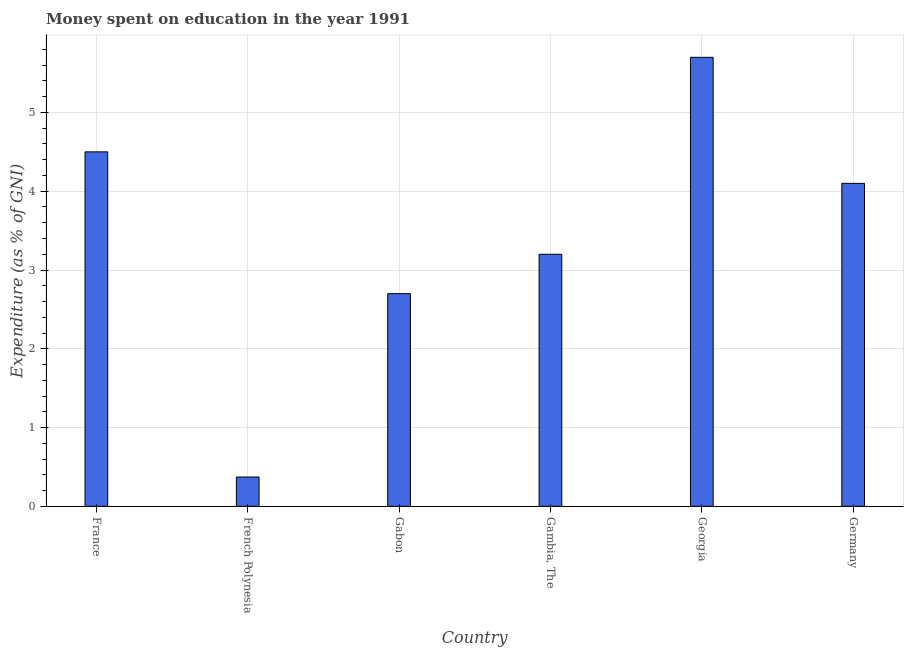What is the title of the graph?
Offer a very short reply. Money spent on education in the year 1991. What is the label or title of the X-axis?
Your answer should be very brief. Country. What is the label or title of the Y-axis?
Offer a terse response. Expenditure (as % of GNI). Across all countries, what is the minimum expenditure on education?
Give a very brief answer. 0.37. In which country was the expenditure on education maximum?
Offer a terse response. Georgia. In which country was the expenditure on education minimum?
Keep it short and to the point. French Polynesia. What is the sum of the expenditure on education?
Give a very brief answer. 20.57. What is the average expenditure on education per country?
Your answer should be very brief. 3.43. What is the median expenditure on education?
Provide a succinct answer. 3.65. In how many countries, is the expenditure on education greater than 4.6 %?
Your answer should be very brief. 1. What is the ratio of the expenditure on education in French Polynesia to that in Gambia, The?
Your answer should be very brief. 0.12. Is the expenditure on education in France less than that in Gambia, The?
Offer a terse response. No. Is the sum of the expenditure on education in French Polynesia and Georgia greater than the maximum expenditure on education across all countries?
Offer a very short reply. Yes. What is the difference between the highest and the lowest expenditure on education?
Make the answer very short. 5.33. Are all the bars in the graph horizontal?
Your answer should be compact. No. How many countries are there in the graph?
Ensure brevity in your answer.  6. What is the difference between two consecutive major ticks on the Y-axis?
Offer a very short reply. 1. What is the Expenditure (as % of GNI) of France?
Offer a very short reply. 4.5. What is the Expenditure (as % of GNI) of French Polynesia?
Your response must be concise. 0.37. What is the Expenditure (as % of GNI) of Georgia?
Give a very brief answer. 5.7. What is the difference between the Expenditure (as % of GNI) in France and French Polynesia?
Ensure brevity in your answer.  4.13. What is the difference between the Expenditure (as % of GNI) in France and Gabon?
Your answer should be compact. 1.8. What is the difference between the Expenditure (as % of GNI) in France and Gambia, The?
Your answer should be very brief. 1.3. What is the difference between the Expenditure (as % of GNI) in France and Georgia?
Ensure brevity in your answer.  -1.2. What is the difference between the Expenditure (as % of GNI) in France and Germany?
Your response must be concise. 0.4. What is the difference between the Expenditure (as % of GNI) in French Polynesia and Gabon?
Your answer should be very brief. -2.33. What is the difference between the Expenditure (as % of GNI) in French Polynesia and Gambia, The?
Keep it short and to the point. -2.83. What is the difference between the Expenditure (as % of GNI) in French Polynesia and Georgia?
Ensure brevity in your answer.  -5.33. What is the difference between the Expenditure (as % of GNI) in French Polynesia and Germany?
Provide a short and direct response. -3.73. What is the difference between the Expenditure (as % of GNI) in Gabon and Gambia, The?
Your response must be concise. -0.5. What is the difference between the Expenditure (as % of GNI) in Gabon and Germany?
Ensure brevity in your answer.  -1.4. What is the difference between the Expenditure (as % of GNI) in Gambia, The and Georgia?
Your answer should be compact. -2.5. What is the difference between the Expenditure (as % of GNI) in Gambia, The and Germany?
Your answer should be very brief. -0.9. What is the ratio of the Expenditure (as % of GNI) in France to that in French Polynesia?
Give a very brief answer. 12.09. What is the ratio of the Expenditure (as % of GNI) in France to that in Gabon?
Make the answer very short. 1.67. What is the ratio of the Expenditure (as % of GNI) in France to that in Gambia, The?
Offer a very short reply. 1.41. What is the ratio of the Expenditure (as % of GNI) in France to that in Georgia?
Keep it short and to the point. 0.79. What is the ratio of the Expenditure (as % of GNI) in France to that in Germany?
Make the answer very short. 1.1. What is the ratio of the Expenditure (as % of GNI) in French Polynesia to that in Gabon?
Offer a very short reply. 0.14. What is the ratio of the Expenditure (as % of GNI) in French Polynesia to that in Gambia, The?
Offer a very short reply. 0.12. What is the ratio of the Expenditure (as % of GNI) in French Polynesia to that in Georgia?
Your answer should be compact. 0.07. What is the ratio of the Expenditure (as % of GNI) in French Polynesia to that in Germany?
Keep it short and to the point. 0.09. What is the ratio of the Expenditure (as % of GNI) in Gabon to that in Gambia, The?
Provide a succinct answer. 0.84. What is the ratio of the Expenditure (as % of GNI) in Gabon to that in Georgia?
Keep it short and to the point. 0.47. What is the ratio of the Expenditure (as % of GNI) in Gabon to that in Germany?
Your response must be concise. 0.66. What is the ratio of the Expenditure (as % of GNI) in Gambia, The to that in Georgia?
Keep it short and to the point. 0.56. What is the ratio of the Expenditure (as % of GNI) in Gambia, The to that in Germany?
Ensure brevity in your answer.  0.78. What is the ratio of the Expenditure (as % of GNI) in Georgia to that in Germany?
Offer a terse response. 1.39. 